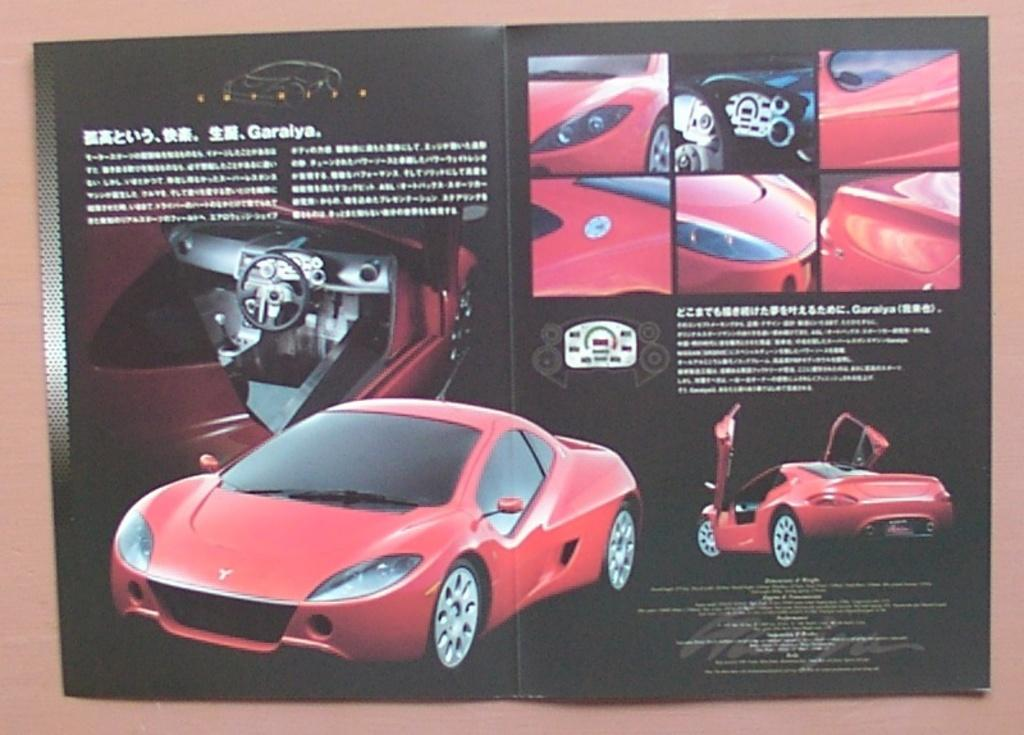What type of image is being described? The image is a poster. What is the main subject of the poster? There is a car depicted on the poster. Can you describe the car's appearance on the poster? The car's parts are visible on the poster. What type of vest is the car wearing in the image? There is no vest present in the image, as the subject is a car and not a person. 